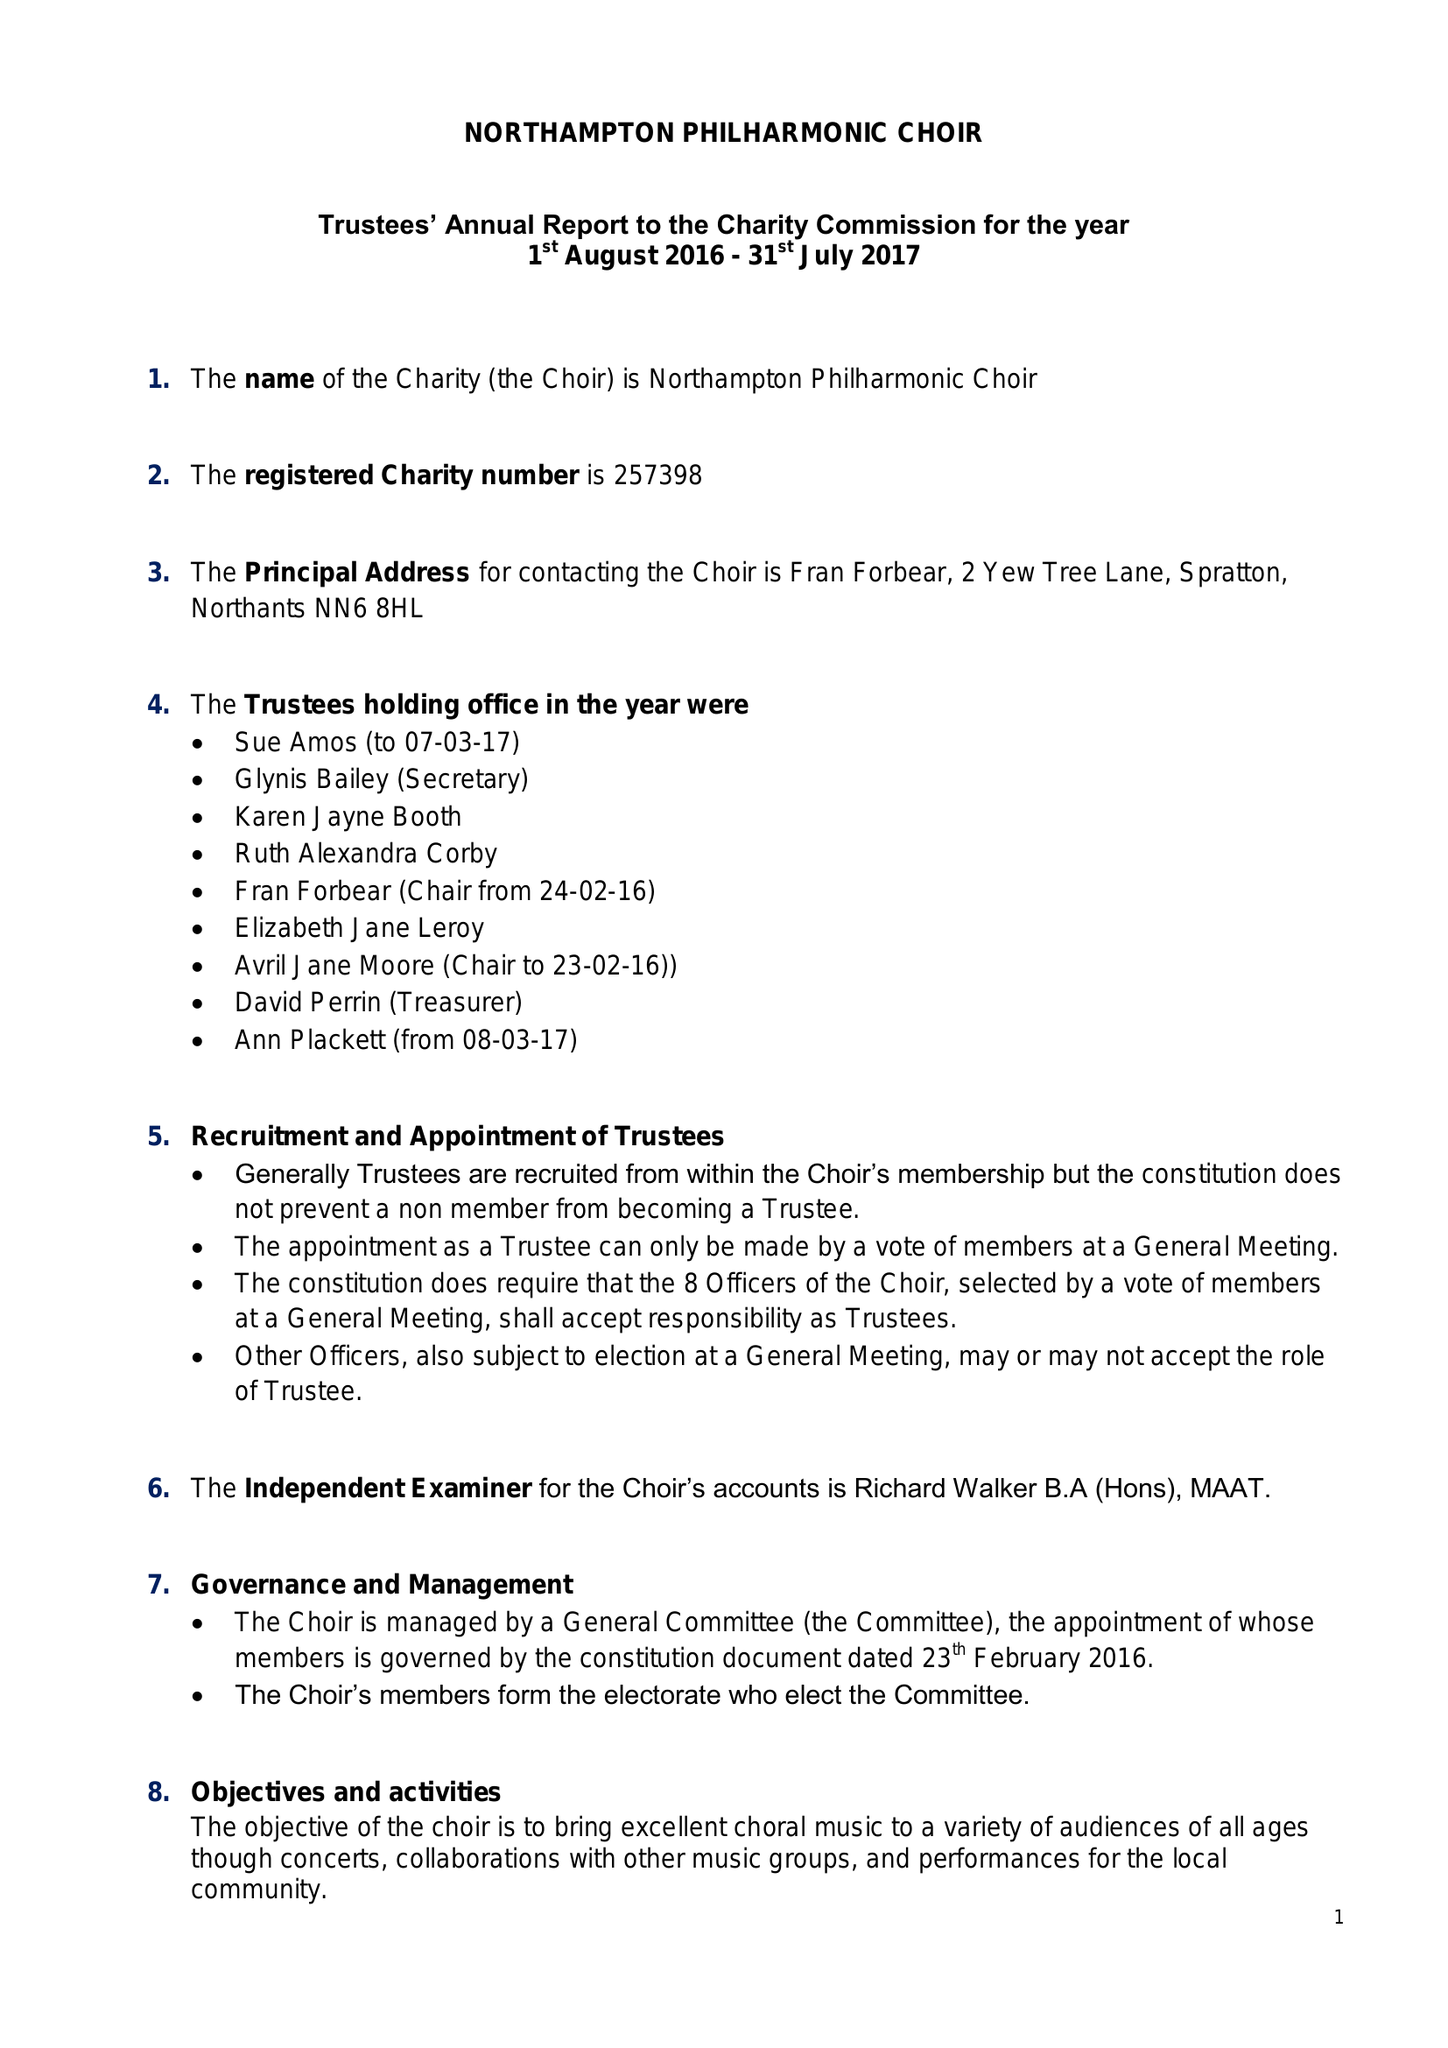What is the value for the charity_number?
Answer the question using a single word or phrase. 257398 